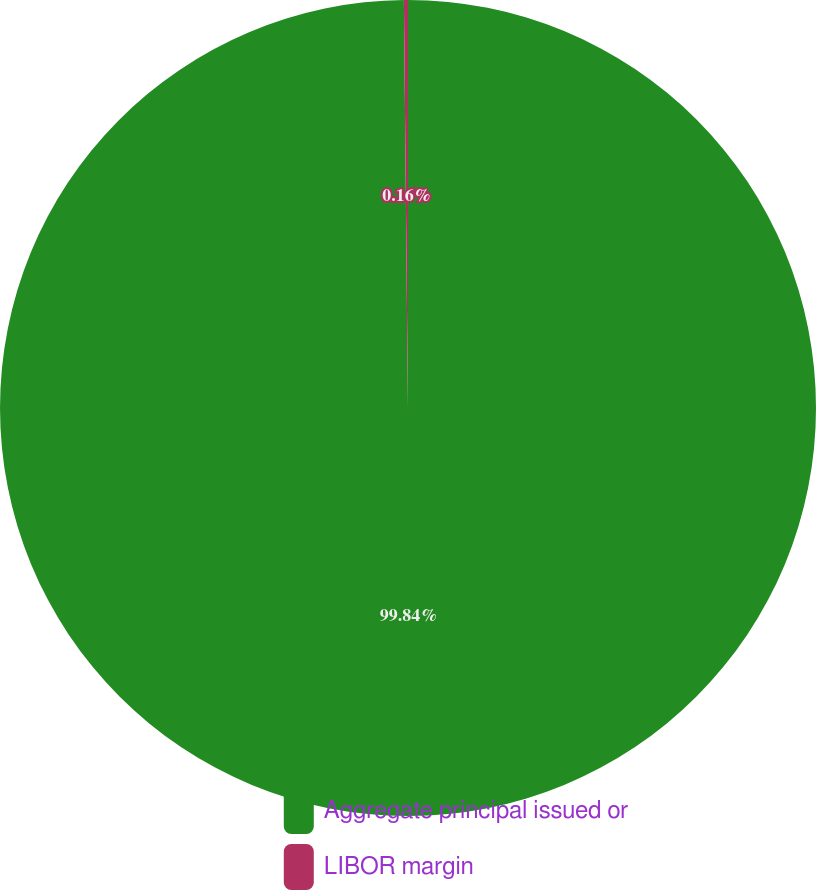<chart> <loc_0><loc_0><loc_500><loc_500><pie_chart><fcel>Aggregate principal issued or<fcel>LIBOR margin<nl><fcel>99.84%<fcel>0.16%<nl></chart> 